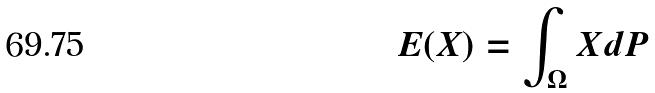Convert formula to latex. <formula><loc_0><loc_0><loc_500><loc_500>E ( X ) = \int _ { \Omega } X d P</formula> 